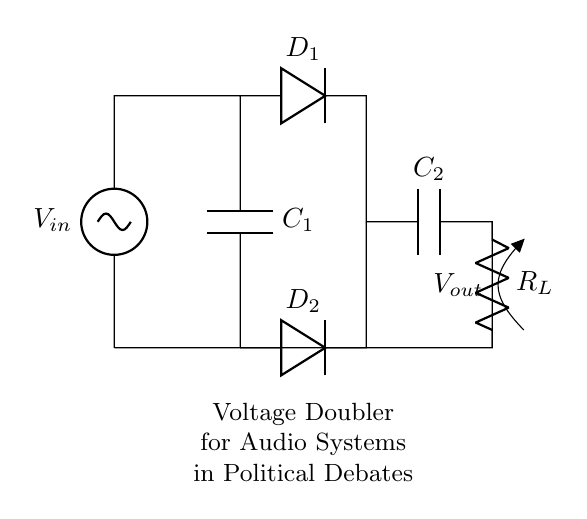What type of circuit is this? This circuit is a voltage doubler rectifier circuit, designed to double the input voltage for high-output applications.
Answer: Voltage doubler rectifier What are the components used in this circuit? The circuit consists of two diodes (D1 and D2), two capacitors (C1 and C2), and a load resistor (R_L).
Answer: Diodes, capacitors, resistor What is the function of capacitor C1? Capacitor C1 acts as the energy storage element that charges up when the input voltage is applied, playing a key role in doubling the voltage.
Answer: Energy storage How many diodes are in the circuit? There are two diodes connected in this voltage doubler rectifier circuit, which help to rectify the alternating current.
Answer: Two What is the role of the load resistor R_L? The load resistor R_L represents the load in the circuit where the output voltage is delivered, indicating how much current the circuit can supply.
Answer: Load representation What is the output voltage compared to the input voltage? The output voltage is approximately double the input voltage due to the configuration of the voltage doubler circuit.
Answer: Double What happens to the capacitors when the circuit is operating? The capacitors charge during the positive half-cycle and discharge into the load during the negative half-cycle, smoothing the output voltage.
Answer: Charge and discharge 